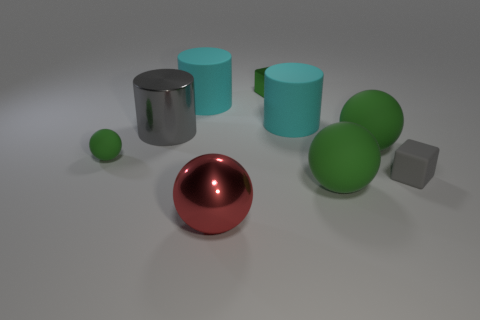Subtract all green spheres. How many were subtracted if there are1green spheres left? 2 Subtract all small spheres. How many spheres are left? 3 Subtract 1 cylinders. How many cylinders are left? 2 Subtract all cyan cubes. How many green spheres are left? 3 Subtract all red balls. How many balls are left? 3 Add 1 tiny rubber objects. How many objects exist? 10 Subtract all gray balls. Subtract all red cubes. How many balls are left? 4 Subtract all balls. How many objects are left? 5 Subtract all spheres. Subtract all big shiny cylinders. How many objects are left? 4 Add 2 big matte things. How many big matte things are left? 6 